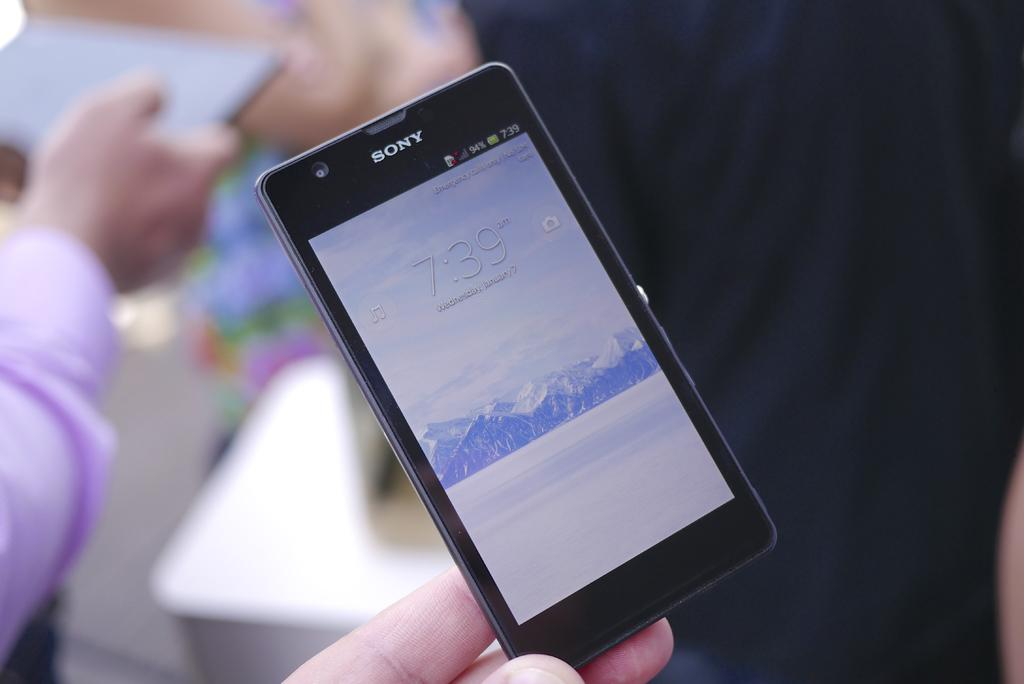<image>
Give a short and clear explanation of the subsequent image. A person holds a small Sony cell phone in their hand. 